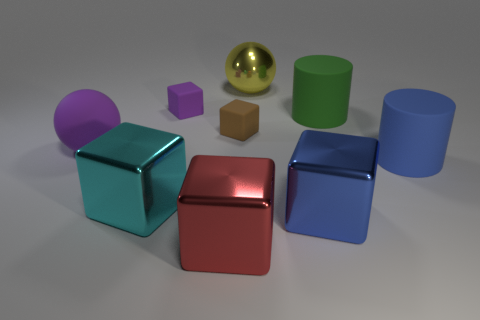Subtract all red blocks. How many blocks are left? 4 Subtract all cyan blocks. How many blocks are left? 4 Subtract all gray blocks. Subtract all yellow cylinders. How many blocks are left? 5 Subtract all cylinders. How many objects are left? 7 Subtract all green rubber objects. Subtract all big balls. How many objects are left? 6 Add 5 tiny matte things. How many tiny matte things are left? 7 Add 1 tiny gray shiny balls. How many tiny gray shiny balls exist? 1 Subtract 0 blue spheres. How many objects are left? 9 